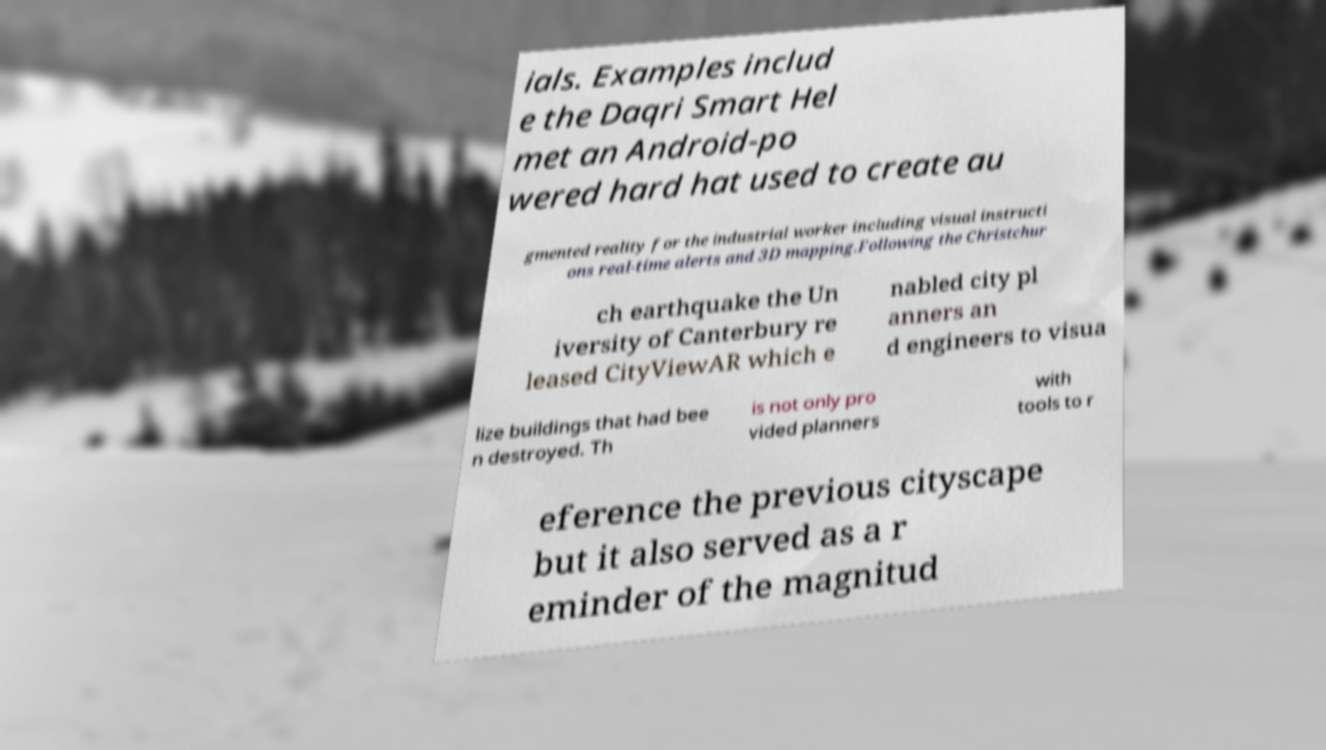Please identify and transcribe the text found in this image. ials. Examples includ e the Daqri Smart Hel met an Android-po wered hard hat used to create au gmented reality for the industrial worker including visual instructi ons real-time alerts and 3D mapping.Following the Christchur ch earthquake the Un iversity of Canterbury re leased CityViewAR which e nabled city pl anners an d engineers to visua lize buildings that had bee n destroyed. Th is not only pro vided planners with tools to r eference the previous cityscape but it also served as a r eminder of the magnitud 